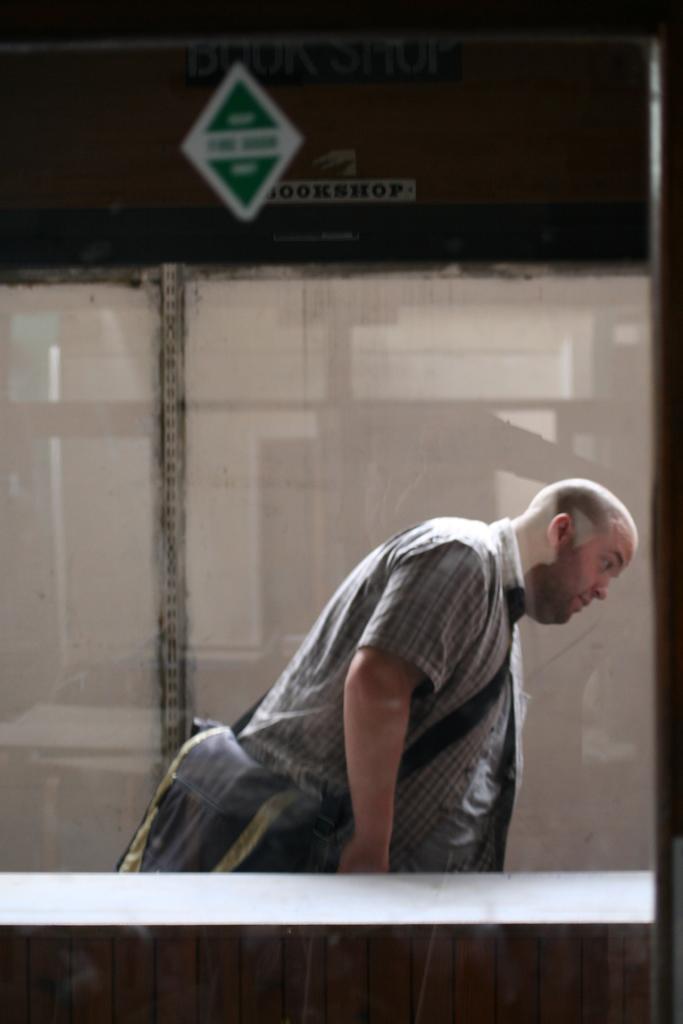Describe this image in one or two sentences. In this image there is a man standing and wearing a bag, beside the building. 